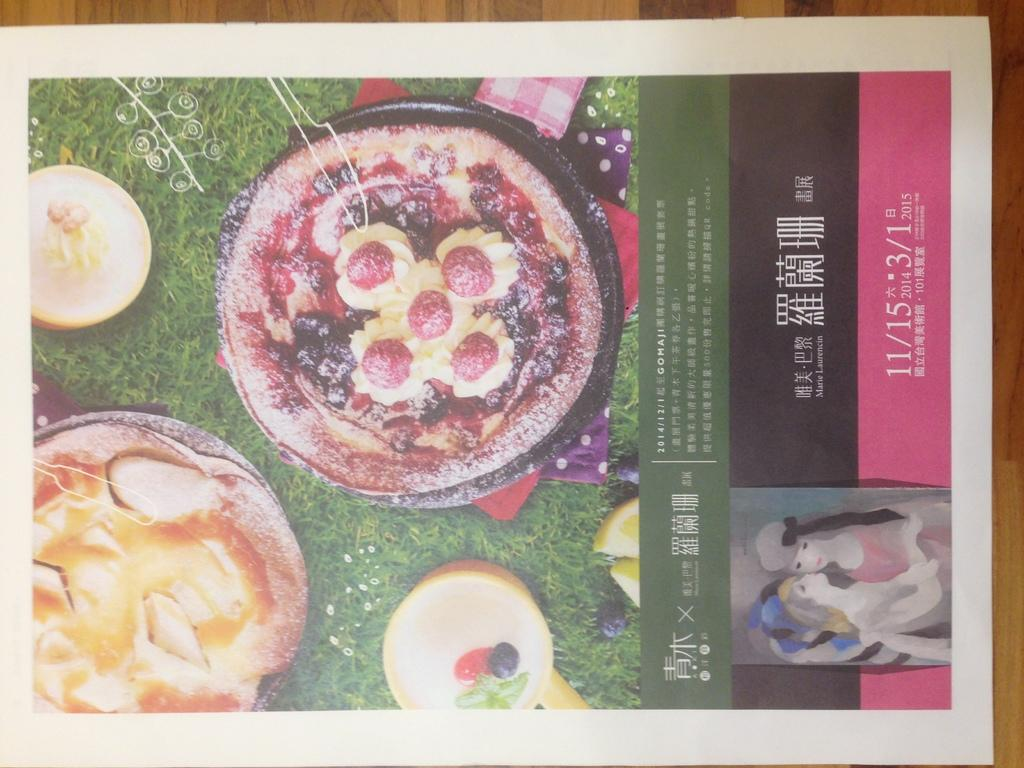<image>
Write a terse but informative summary of the picture. 2014/12/1 Gomaji is written below food choices in this advert. 